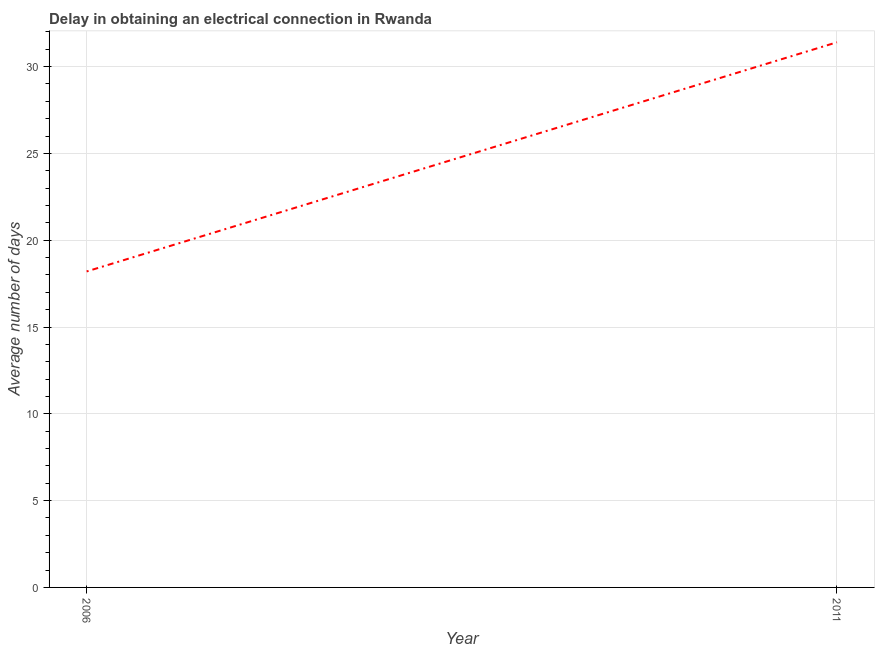What is the dalay in electrical connection in 2006?
Keep it short and to the point. 18.2. Across all years, what is the maximum dalay in electrical connection?
Provide a succinct answer. 31.4. Across all years, what is the minimum dalay in electrical connection?
Your response must be concise. 18.2. What is the sum of the dalay in electrical connection?
Offer a very short reply. 49.6. What is the average dalay in electrical connection per year?
Provide a short and direct response. 24.8. What is the median dalay in electrical connection?
Ensure brevity in your answer.  24.8. What is the ratio of the dalay in electrical connection in 2006 to that in 2011?
Your response must be concise. 0.58. Does the dalay in electrical connection monotonically increase over the years?
Offer a very short reply. Yes. Are the values on the major ticks of Y-axis written in scientific E-notation?
Your response must be concise. No. Does the graph contain any zero values?
Keep it short and to the point. No. Does the graph contain grids?
Your answer should be compact. Yes. What is the title of the graph?
Your answer should be compact. Delay in obtaining an electrical connection in Rwanda. What is the label or title of the X-axis?
Offer a terse response. Year. What is the label or title of the Y-axis?
Give a very brief answer. Average number of days. What is the Average number of days of 2006?
Your answer should be very brief. 18.2. What is the Average number of days of 2011?
Offer a very short reply. 31.4. What is the difference between the Average number of days in 2006 and 2011?
Make the answer very short. -13.2. What is the ratio of the Average number of days in 2006 to that in 2011?
Ensure brevity in your answer.  0.58. 